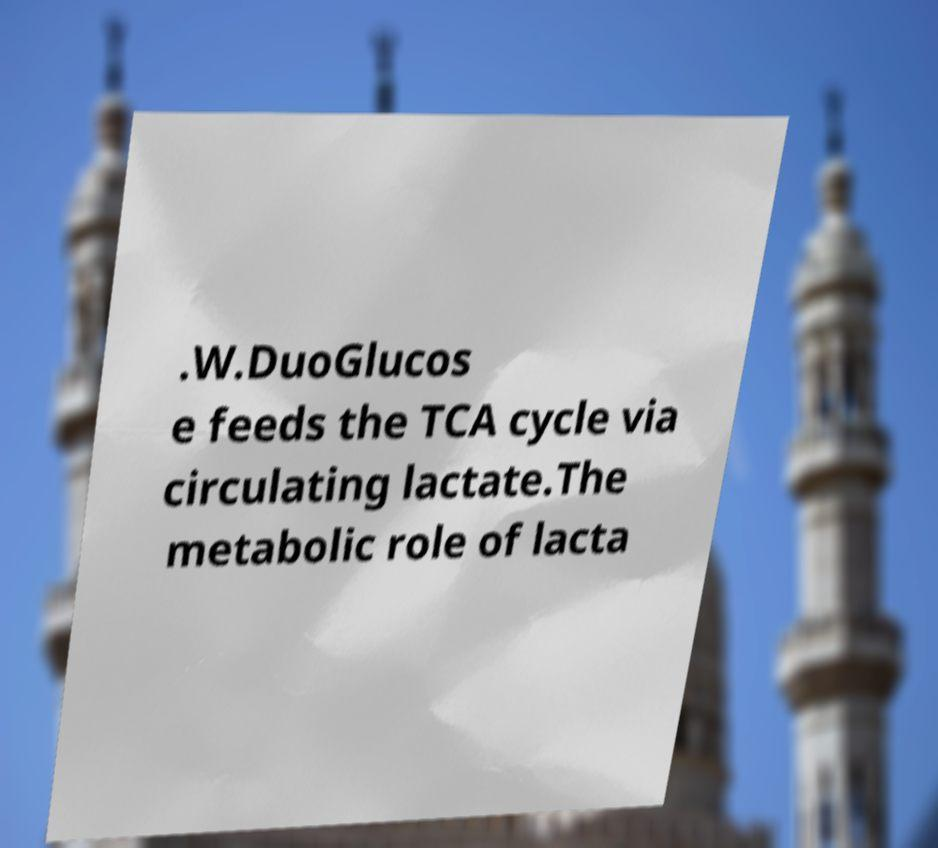Could you extract and type out the text from this image? .W.DuoGlucos e feeds the TCA cycle via circulating lactate.The metabolic role of lacta 